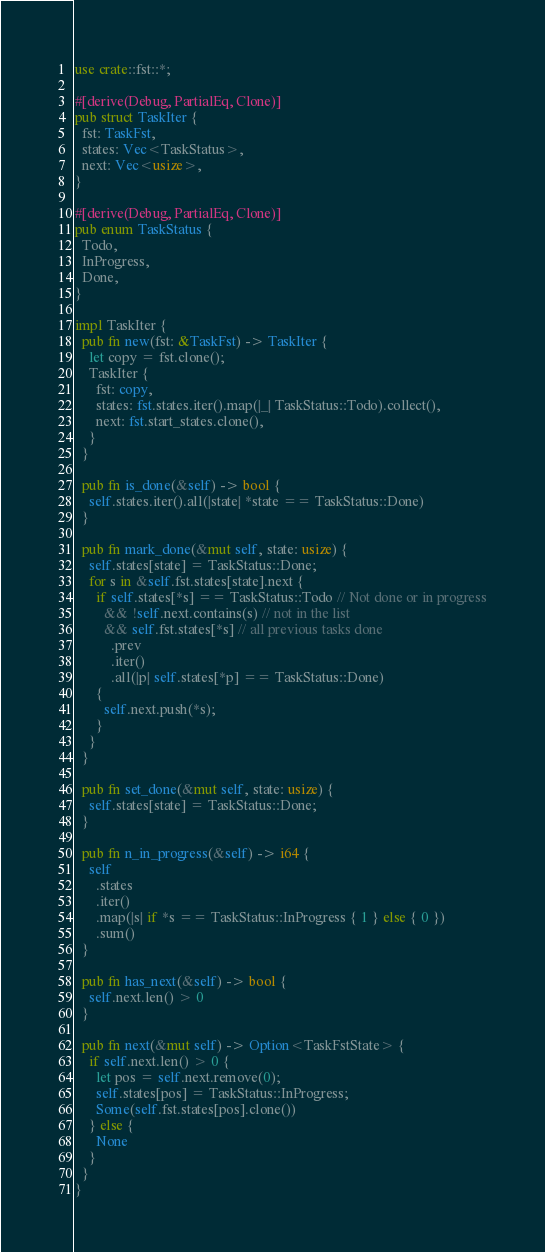Convert code to text. <code><loc_0><loc_0><loc_500><loc_500><_Rust_>use crate::fst::*;

#[derive(Debug, PartialEq, Clone)]
pub struct TaskIter {
  fst: TaskFst,
  states: Vec<TaskStatus>,
  next: Vec<usize>,
}

#[derive(Debug, PartialEq, Clone)]
pub enum TaskStatus {
  Todo,
  InProgress,
  Done,
}

impl TaskIter {
  pub fn new(fst: &TaskFst) -> TaskIter {
    let copy = fst.clone();
    TaskIter {
      fst: copy,
      states: fst.states.iter().map(|_| TaskStatus::Todo).collect(),
      next: fst.start_states.clone(),
    }
  }

  pub fn is_done(&self) -> bool {
    self.states.iter().all(|state| *state == TaskStatus::Done)
  }

  pub fn mark_done(&mut self, state: usize) {
    self.states[state] = TaskStatus::Done;
    for s in &self.fst.states[state].next {
      if self.states[*s] == TaskStatus::Todo // Not done or in progress
        && !self.next.contains(s) // not in the list
        && self.fst.states[*s] // all previous tasks done
          .prev
          .iter()
          .all(|p| self.states[*p] == TaskStatus::Done)
      {
        self.next.push(*s);
      }
    }
  }

  pub fn set_done(&mut self, state: usize) {
    self.states[state] = TaskStatus::Done;
  }

  pub fn n_in_progress(&self) -> i64 {
    self
      .states
      .iter()
      .map(|s| if *s == TaskStatus::InProgress { 1 } else { 0 })
      .sum()
  }

  pub fn has_next(&self) -> bool {
    self.next.len() > 0
  }

  pub fn next(&mut self) -> Option<TaskFstState> {
    if self.next.len() > 0 {
      let pos = self.next.remove(0);
      self.states[pos] = TaskStatus::InProgress;
      Some(self.fst.states[pos].clone())
    } else {
      None
    }
  }
}
</code> 